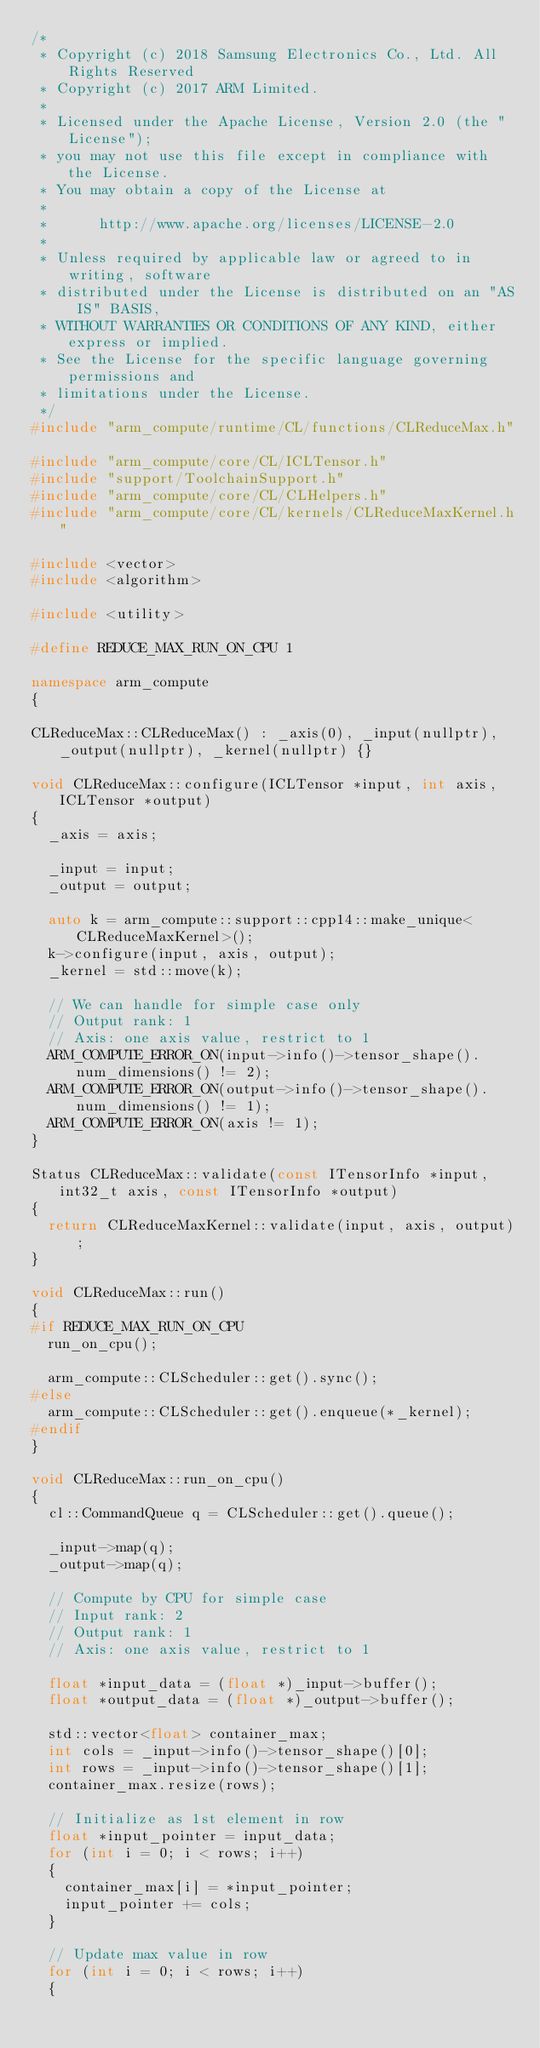Convert code to text. <code><loc_0><loc_0><loc_500><loc_500><_C++_>/*
 * Copyright (c) 2018 Samsung Electronics Co., Ltd. All Rights Reserved
 * Copyright (c) 2017 ARM Limited.
 *
 * Licensed under the Apache License, Version 2.0 (the "License");
 * you may not use this file except in compliance with the License.
 * You may obtain a copy of the License at
 *
 *      http://www.apache.org/licenses/LICENSE-2.0
 *
 * Unless required by applicable law or agreed to in writing, software
 * distributed under the License is distributed on an "AS IS" BASIS,
 * WITHOUT WARRANTIES OR CONDITIONS OF ANY KIND, either express or implied.
 * See the License for the specific language governing permissions and
 * limitations under the License.
 */
#include "arm_compute/runtime/CL/functions/CLReduceMax.h"

#include "arm_compute/core/CL/ICLTensor.h"
#include "support/ToolchainSupport.h"
#include "arm_compute/core/CL/CLHelpers.h"
#include "arm_compute/core/CL/kernels/CLReduceMaxKernel.h"

#include <vector>
#include <algorithm>

#include <utility>

#define REDUCE_MAX_RUN_ON_CPU 1

namespace arm_compute
{

CLReduceMax::CLReduceMax() : _axis(0), _input(nullptr), _output(nullptr), _kernel(nullptr) {}

void CLReduceMax::configure(ICLTensor *input, int axis, ICLTensor *output)
{
  _axis = axis;

  _input = input;
  _output = output;

  auto k = arm_compute::support::cpp14::make_unique<CLReduceMaxKernel>();
  k->configure(input, axis, output);
  _kernel = std::move(k);

  // We can handle for simple case only
  // Output rank: 1
  // Axis: one axis value, restrict to 1
  ARM_COMPUTE_ERROR_ON(input->info()->tensor_shape().num_dimensions() != 2);
  ARM_COMPUTE_ERROR_ON(output->info()->tensor_shape().num_dimensions() != 1);
  ARM_COMPUTE_ERROR_ON(axis != 1);
}

Status CLReduceMax::validate(const ITensorInfo *input, int32_t axis, const ITensorInfo *output)
{
  return CLReduceMaxKernel::validate(input, axis, output);
}

void CLReduceMax::run()
{
#if REDUCE_MAX_RUN_ON_CPU
  run_on_cpu();

  arm_compute::CLScheduler::get().sync();
#else
  arm_compute::CLScheduler::get().enqueue(*_kernel);
#endif
}

void CLReduceMax::run_on_cpu()
{
  cl::CommandQueue q = CLScheduler::get().queue();

  _input->map(q);
  _output->map(q);

  // Compute by CPU for simple case
  // Input rank: 2
  // Output rank: 1
  // Axis: one axis value, restrict to 1

  float *input_data = (float *)_input->buffer();
  float *output_data = (float *)_output->buffer();

  std::vector<float> container_max;
  int cols = _input->info()->tensor_shape()[0];
  int rows = _input->info()->tensor_shape()[1];
  container_max.resize(rows);

  // Initialize as 1st element in row
  float *input_pointer = input_data;
  for (int i = 0; i < rows; i++)
  {
    container_max[i] = *input_pointer;
    input_pointer += cols;
  }

  // Update max value in row
  for (int i = 0; i < rows; i++)
  {</code> 